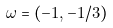<formula> <loc_0><loc_0><loc_500><loc_500>\omega = ( - 1 , - 1 / 3 )</formula> 